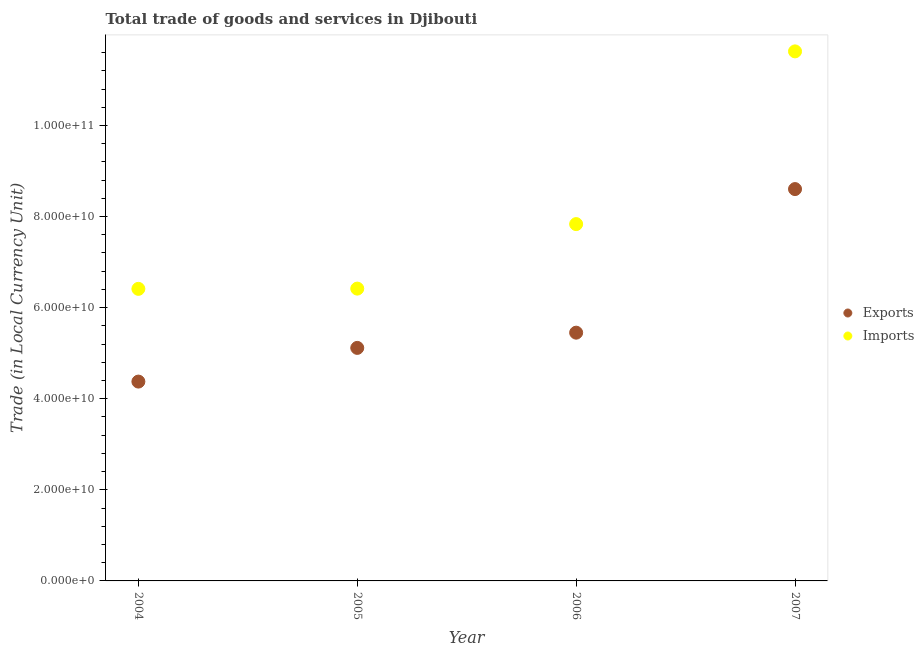How many different coloured dotlines are there?
Offer a terse response. 2. What is the imports of goods and services in 2006?
Provide a short and direct response. 7.83e+1. Across all years, what is the maximum export of goods and services?
Provide a succinct answer. 8.60e+1. Across all years, what is the minimum export of goods and services?
Your answer should be compact. 4.38e+1. What is the total imports of goods and services in the graph?
Offer a very short reply. 3.23e+11. What is the difference between the export of goods and services in 2006 and that in 2007?
Your response must be concise. -3.15e+1. What is the difference between the export of goods and services in 2007 and the imports of goods and services in 2005?
Your response must be concise. 2.19e+1. What is the average imports of goods and services per year?
Offer a terse response. 8.07e+1. In the year 2007, what is the difference between the export of goods and services and imports of goods and services?
Your answer should be compact. -3.02e+1. In how many years, is the imports of goods and services greater than 104000000000 LCU?
Make the answer very short. 1. What is the ratio of the imports of goods and services in 2004 to that in 2007?
Offer a terse response. 0.55. Is the imports of goods and services in 2004 less than that in 2005?
Your answer should be compact. Yes. What is the difference between the highest and the second highest imports of goods and services?
Offer a terse response. 3.79e+1. What is the difference between the highest and the lowest export of goods and services?
Ensure brevity in your answer.  4.23e+1. In how many years, is the export of goods and services greater than the average export of goods and services taken over all years?
Keep it short and to the point. 1. Is the export of goods and services strictly less than the imports of goods and services over the years?
Offer a very short reply. Yes. How many dotlines are there?
Your response must be concise. 2. How many years are there in the graph?
Give a very brief answer. 4. What is the difference between two consecutive major ticks on the Y-axis?
Your answer should be compact. 2.00e+1. Does the graph contain grids?
Offer a very short reply. No. What is the title of the graph?
Your answer should be very brief. Total trade of goods and services in Djibouti. Does "Residents" appear as one of the legend labels in the graph?
Give a very brief answer. No. What is the label or title of the Y-axis?
Keep it short and to the point. Trade (in Local Currency Unit). What is the Trade (in Local Currency Unit) in Exports in 2004?
Keep it short and to the point. 4.38e+1. What is the Trade (in Local Currency Unit) of Imports in 2004?
Provide a short and direct response. 6.41e+1. What is the Trade (in Local Currency Unit) of Exports in 2005?
Keep it short and to the point. 5.12e+1. What is the Trade (in Local Currency Unit) in Imports in 2005?
Make the answer very short. 6.42e+1. What is the Trade (in Local Currency Unit) in Exports in 2006?
Your answer should be compact. 5.45e+1. What is the Trade (in Local Currency Unit) of Imports in 2006?
Keep it short and to the point. 7.83e+1. What is the Trade (in Local Currency Unit) in Exports in 2007?
Your answer should be compact. 8.60e+1. What is the Trade (in Local Currency Unit) of Imports in 2007?
Keep it short and to the point. 1.16e+11. Across all years, what is the maximum Trade (in Local Currency Unit) in Exports?
Ensure brevity in your answer.  8.60e+1. Across all years, what is the maximum Trade (in Local Currency Unit) in Imports?
Offer a very short reply. 1.16e+11. Across all years, what is the minimum Trade (in Local Currency Unit) of Exports?
Your answer should be compact. 4.38e+1. Across all years, what is the minimum Trade (in Local Currency Unit) of Imports?
Make the answer very short. 6.41e+1. What is the total Trade (in Local Currency Unit) of Exports in the graph?
Your response must be concise. 2.35e+11. What is the total Trade (in Local Currency Unit) in Imports in the graph?
Offer a very short reply. 3.23e+11. What is the difference between the Trade (in Local Currency Unit) in Exports in 2004 and that in 2005?
Provide a succinct answer. -7.40e+09. What is the difference between the Trade (in Local Currency Unit) of Imports in 2004 and that in 2005?
Your response must be concise. -5.33e+07. What is the difference between the Trade (in Local Currency Unit) of Exports in 2004 and that in 2006?
Your response must be concise. -1.07e+1. What is the difference between the Trade (in Local Currency Unit) of Imports in 2004 and that in 2006?
Your response must be concise. -1.42e+1. What is the difference between the Trade (in Local Currency Unit) of Exports in 2004 and that in 2007?
Provide a short and direct response. -4.23e+1. What is the difference between the Trade (in Local Currency Unit) of Imports in 2004 and that in 2007?
Offer a terse response. -5.21e+1. What is the difference between the Trade (in Local Currency Unit) in Exports in 2005 and that in 2006?
Offer a terse response. -3.34e+09. What is the difference between the Trade (in Local Currency Unit) of Imports in 2005 and that in 2006?
Your response must be concise. -1.42e+1. What is the difference between the Trade (in Local Currency Unit) in Exports in 2005 and that in 2007?
Keep it short and to the point. -3.49e+1. What is the difference between the Trade (in Local Currency Unit) of Imports in 2005 and that in 2007?
Make the answer very short. -5.21e+1. What is the difference between the Trade (in Local Currency Unit) of Exports in 2006 and that in 2007?
Offer a terse response. -3.15e+1. What is the difference between the Trade (in Local Currency Unit) in Imports in 2006 and that in 2007?
Ensure brevity in your answer.  -3.79e+1. What is the difference between the Trade (in Local Currency Unit) of Exports in 2004 and the Trade (in Local Currency Unit) of Imports in 2005?
Ensure brevity in your answer.  -2.04e+1. What is the difference between the Trade (in Local Currency Unit) of Exports in 2004 and the Trade (in Local Currency Unit) of Imports in 2006?
Ensure brevity in your answer.  -3.46e+1. What is the difference between the Trade (in Local Currency Unit) of Exports in 2004 and the Trade (in Local Currency Unit) of Imports in 2007?
Your answer should be very brief. -7.25e+1. What is the difference between the Trade (in Local Currency Unit) in Exports in 2005 and the Trade (in Local Currency Unit) in Imports in 2006?
Offer a very short reply. -2.72e+1. What is the difference between the Trade (in Local Currency Unit) in Exports in 2005 and the Trade (in Local Currency Unit) in Imports in 2007?
Offer a very short reply. -6.51e+1. What is the difference between the Trade (in Local Currency Unit) in Exports in 2006 and the Trade (in Local Currency Unit) in Imports in 2007?
Give a very brief answer. -6.18e+1. What is the average Trade (in Local Currency Unit) of Exports per year?
Your answer should be compact. 5.89e+1. What is the average Trade (in Local Currency Unit) of Imports per year?
Make the answer very short. 8.07e+1. In the year 2004, what is the difference between the Trade (in Local Currency Unit) of Exports and Trade (in Local Currency Unit) of Imports?
Keep it short and to the point. -2.04e+1. In the year 2005, what is the difference between the Trade (in Local Currency Unit) in Exports and Trade (in Local Currency Unit) in Imports?
Your answer should be compact. -1.30e+1. In the year 2006, what is the difference between the Trade (in Local Currency Unit) in Exports and Trade (in Local Currency Unit) in Imports?
Your answer should be very brief. -2.38e+1. In the year 2007, what is the difference between the Trade (in Local Currency Unit) in Exports and Trade (in Local Currency Unit) in Imports?
Your answer should be very brief. -3.02e+1. What is the ratio of the Trade (in Local Currency Unit) of Exports in 2004 to that in 2005?
Your answer should be very brief. 0.86. What is the ratio of the Trade (in Local Currency Unit) in Imports in 2004 to that in 2005?
Offer a terse response. 1. What is the ratio of the Trade (in Local Currency Unit) in Exports in 2004 to that in 2006?
Your answer should be very brief. 0.8. What is the ratio of the Trade (in Local Currency Unit) in Imports in 2004 to that in 2006?
Provide a short and direct response. 0.82. What is the ratio of the Trade (in Local Currency Unit) of Exports in 2004 to that in 2007?
Offer a terse response. 0.51. What is the ratio of the Trade (in Local Currency Unit) in Imports in 2004 to that in 2007?
Provide a succinct answer. 0.55. What is the ratio of the Trade (in Local Currency Unit) of Exports in 2005 to that in 2006?
Ensure brevity in your answer.  0.94. What is the ratio of the Trade (in Local Currency Unit) of Imports in 2005 to that in 2006?
Make the answer very short. 0.82. What is the ratio of the Trade (in Local Currency Unit) in Exports in 2005 to that in 2007?
Give a very brief answer. 0.59. What is the ratio of the Trade (in Local Currency Unit) of Imports in 2005 to that in 2007?
Provide a succinct answer. 0.55. What is the ratio of the Trade (in Local Currency Unit) of Exports in 2006 to that in 2007?
Offer a very short reply. 0.63. What is the ratio of the Trade (in Local Currency Unit) of Imports in 2006 to that in 2007?
Make the answer very short. 0.67. What is the difference between the highest and the second highest Trade (in Local Currency Unit) in Exports?
Make the answer very short. 3.15e+1. What is the difference between the highest and the second highest Trade (in Local Currency Unit) of Imports?
Your answer should be very brief. 3.79e+1. What is the difference between the highest and the lowest Trade (in Local Currency Unit) of Exports?
Give a very brief answer. 4.23e+1. What is the difference between the highest and the lowest Trade (in Local Currency Unit) of Imports?
Provide a succinct answer. 5.21e+1. 